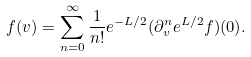<formula> <loc_0><loc_0><loc_500><loc_500>f ( v ) = \sum _ { n = 0 } ^ { \infty } \frac { 1 } { n ! } e ^ { - L / 2 } ( \partial _ { v } ^ { n } e ^ { L / 2 } f ) ( 0 ) .</formula> 